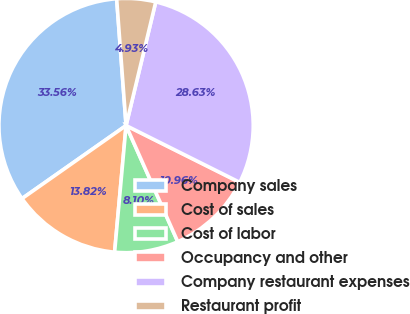<chart> <loc_0><loc_0><loc_500><loc_500><pie_chart><fcel>Company sales<fcel>Cost of sales<fcel>Cost of labor<fcel>Occupancy and other<fcel>Company restaurant expenses<fcel>Restaurant profit<nl><fcel>33.56%<fcel>13.82%<fcel>8.1%<fcel>10.96%<fcel>28.63%<fcel>4.93%<nl></chart> 